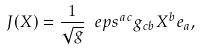<formula> <loc_0><loc_0><loc_500><loc_500>\ J ( X ) = \frac { 1 } { \sqrt { g } } \ e p s ^ { a c } g _ { c b } X ^ { b } e _ { a } ,</formula> 